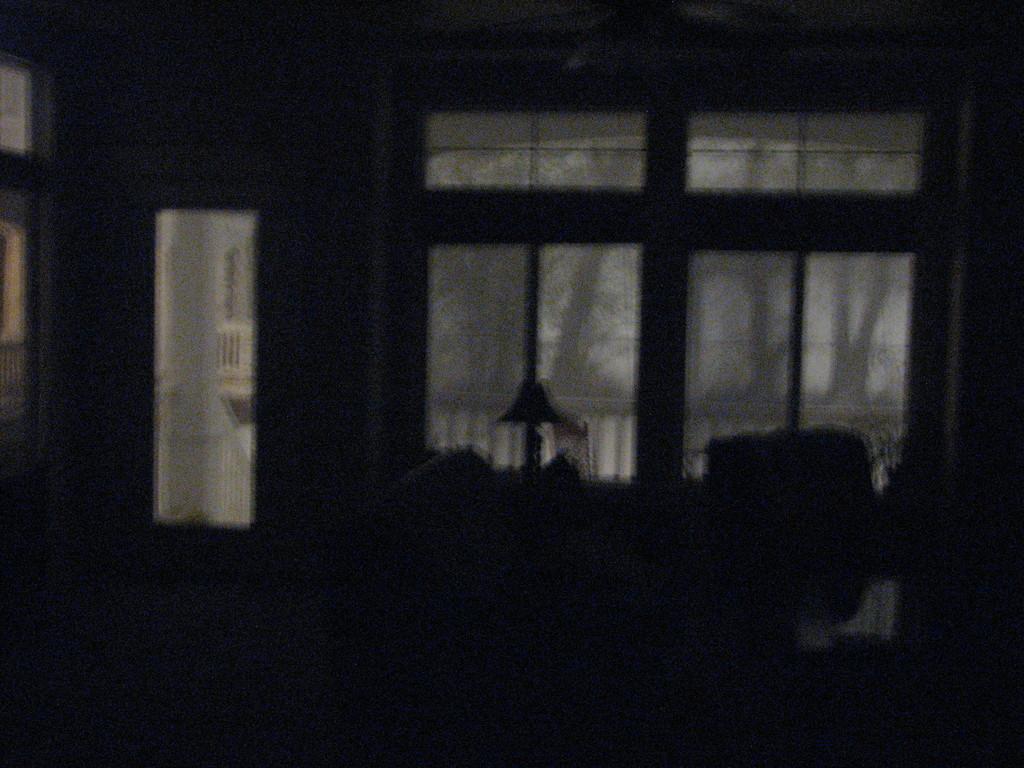Could you give a brief overview of what you see in this image? This image is clicked inside a house. In the middle there are windows, glasses, door. 